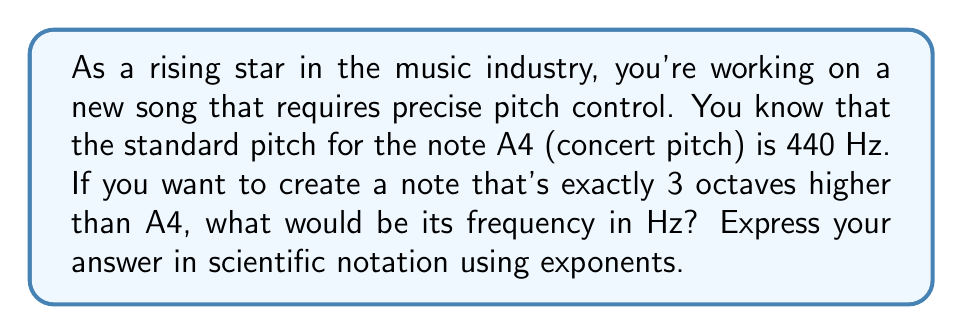Can you solve this math problem? Let's approach this step-by-step:

1) First, recall that each octave represents a doubling of frequency. So, going up 3 octaves means doubling the frequency 3 times.

2) We can express this mathematically as:

   $$f = 440 \cdot 2^3$$

   Where $f$ is the new frequency and 440 Hz is the frequency of A4.

3) Let's calculate:

   $$f = 440 \cdot 2^3 = 440 \cdot 8 = 3520$$

4) Now, we need to express this in scientific notation. In scientific notation, we write numbers as $a \cdot 10^n$, where $1 \leq |a| < 10$ and $n$ is an integer.

5) We can write 3520 as:

   $$3520 = 3.52 \cdot 10^3$$

6) Therefore, the frequency of the note 3 octaves above A4 is $3.52 \cdot 10^3$ Hz.
Answer: $3.52 \cdot 10^3$ Hz 